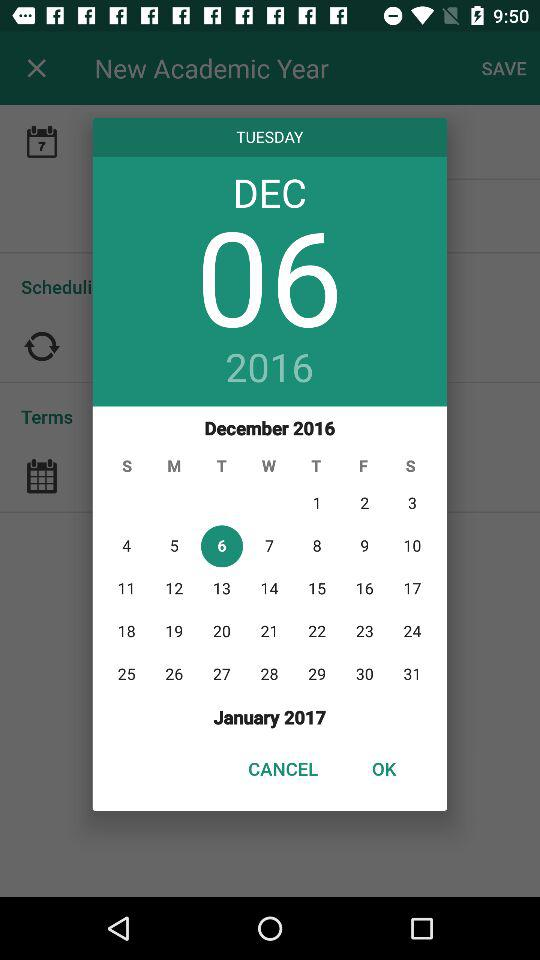What is the selected date? The selected date is Tuesday, December 6, 2016. 